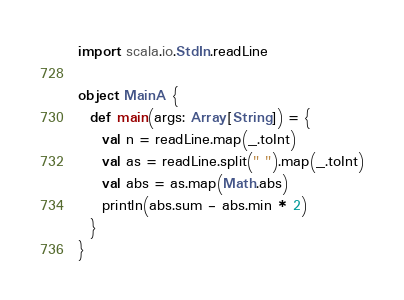<code> <loc_0><loc_0><loc_500><loc_500><_Scala_>import scala.io.StdIn.readLine

object MainA {
  def main(args: Array[String]) = {
    val n = readLine.map(_.toInt)
    val as = readLine.split(" ").map(_.toInt)
    val abs = as.map(Math.abs)
    println(abs.sum - abs.min * 2)
  }
}
</code> 